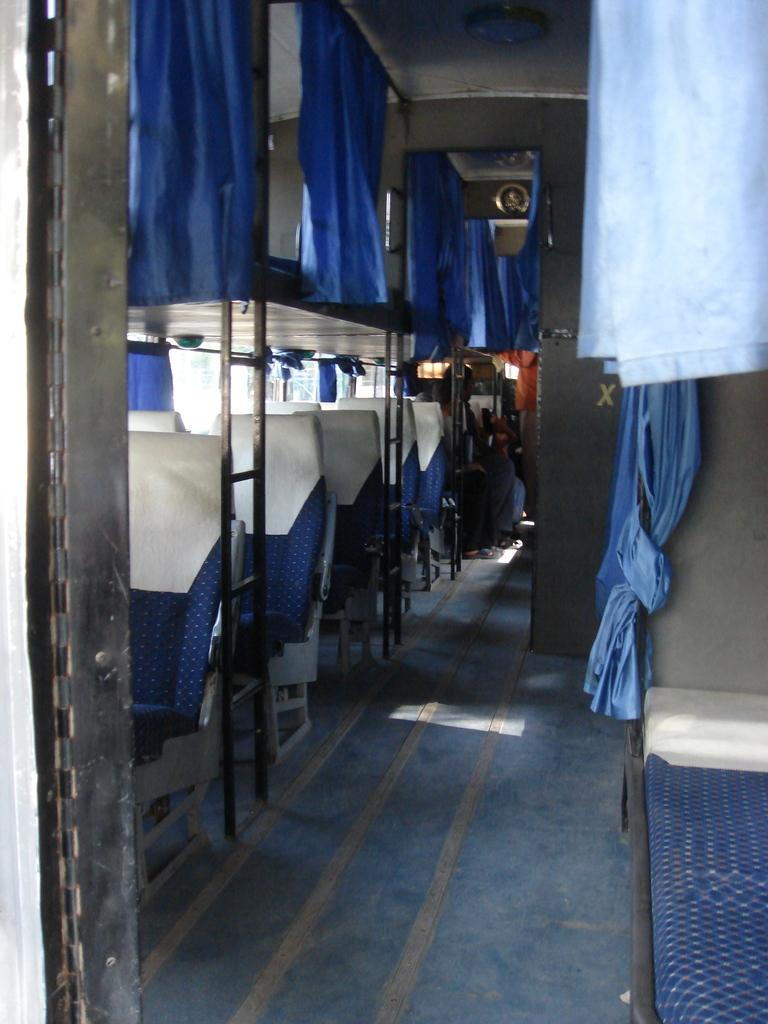What type of furniture is present in the image? There are seats in the image. Where are the seats located? The seats are in a bus. Can you describe the people in the image? There are people sitting in the background of the image. What type of window treatment is visible in the image? There are curtains visible in the image. What type of lighting is present in the image? There are lights in the image. What type of tree is growing in the aisle of the bus in the image? There is no tree growing in the aisle of the bus in the image. What type of boot is being worn by the person sitting in the front row of the bus? There is no information about the type of footwear being worn by anyone in the image. 